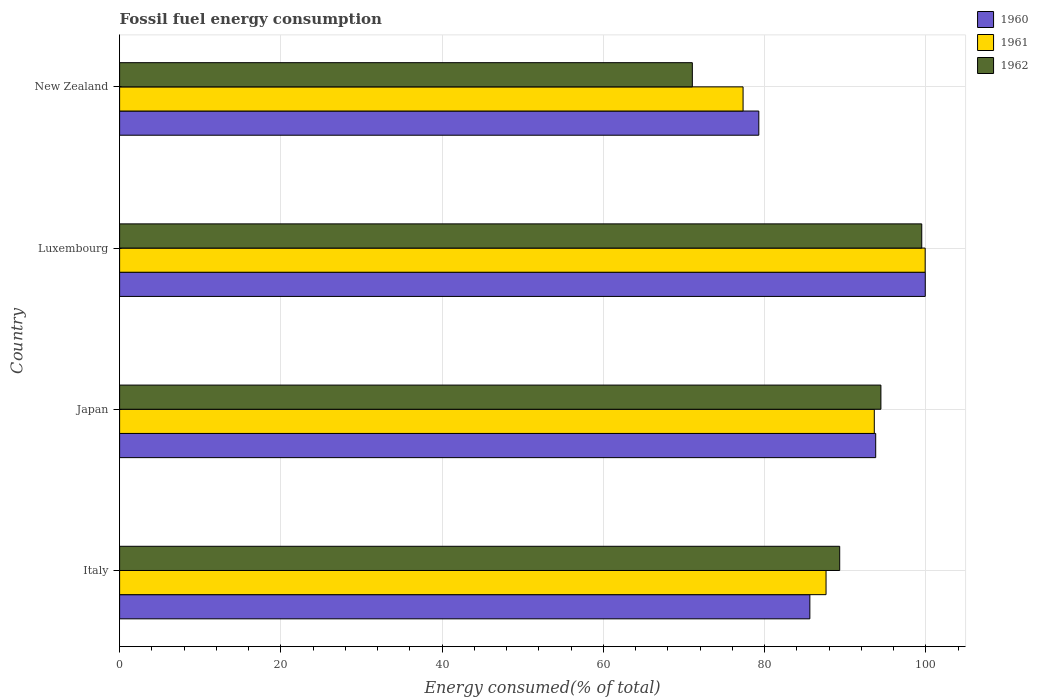How many different coloured bars are there?
Ensure brevity in your answer.  3. Are the number of bars per tick equal to the number of legend labels?
Provide a short and direct response. Yes. Are the number of bars on each tick of the Y-axis equal?
Make the answer very short. Yes. How many bars are there on the 1st tick from the bottom?
Make the answer very short. 3. What is the percentage of energy consumed in 1960 in New Zealand?
Keep it short and to the point. 79.28. Across all countries, what is the maximum percentage of energy consumed in 1960?
Your answer should be compact. 99.92. Across all countries, what is the minimum percentage of energy consumed in 1962?
Provide a succinct answer. 71.04. In which country was the percentage of energy consumed in 1960 maximum?
Keep it short and to the point. Luxembourg. In which country was the percentage of energy consumed in 1961 minimum?
Ensure brevity in your answer.  New Zealand. What is the total percentage of energy consumed in 1962 in the graph?
Your answer should be very brief. 354.26. What is the difference between the percentage of energy consumed in 1961 in Italy and that in Luxembourg?
Offer a very short reply. -12.3. What is the difference between the percentage of energy consumed in 1961 in Italy and the percentage of energy consumed in 1960 in Japan?
Make the answer very short. -6.16. What is the average percentage of energy consumed in 1960 per country?
Offer a very short reply. 89.65. What is the difference between the percentage of energy consumed in 1962 and percentage of energy consumed in 1961 in Japan?
Give a very brief answer. 0.82. What is the ratio of the percentage of energy consumed in 1960 in Japan to that in Luxembourg?
Your answer should be very brief. 0.94. Is the percentage of energy consumed in 1960 in Italy less than that in Japan?
Your answer should be very brief. Yes. Is the difference between the percentage of energy consumed in 1962 in Italy and Luxembourg greater than the difference between the percentage of energy consumed in 1961 in Italy and Luxembourg?
Your answer should be very brief. Yes. What is the difference between the highest and the second highest percentage of energy consumed in 1961?
Make the answer very short. 6.31. What is the difference between the highest and the lowest percentage of energy consumed in 1961?
Offer a terse response. 22.58. Is the sum of the percentage of energy consumed in 1962 in Italy and Japan greater than the maximum percentage of energy consumed in 1960 across all countries?
Ensure brevity in your answer.  Yes. What does the 1st bar from the top in Luxembourg represents?
Offer a terse response. 1962. Is it the case that in every country, the sum of the percentage of energy consumed in 1960 and percentage of energy consumed in 1961 is greater than the percentage of energy consumed in 1962?
Offer a very short reply. Yes. How many countries are there in the graph?
Give a very brief answer. 4. What is the difference between two consecutive major ticks on the X-axis?
Provide a short and direct response. 20. Are the values on the major ticks of X-axis written in scientific E-notation?
Make the answer very short. No. Does the graph contain any zero values?
Offer a very short reply. No. Does the graph contain grids?
Keep it short and to the point. Yes. Where does the legend appear in the graph?
Give a very brief answer. Top right. How are the legend labels stacked?
Offer a very short reply. Vertical. What is the title of the graph?
Offer a terse response. Fossil fuel energy consumption. Does "2002" appear as one of the legend labels in the graph?
Give a very brief answer. No. What is the label or title of the X-axis?
Make the answer very short. Energy consumed(% of total). What is the label or title of the Y-axis?
Provide a short and direct response. Country. What is the Energy consumed(% of total) in 1960 in Italy?
Your answer should be compact. 85.61. What is the Energy consumed(% of total) of 1961 in Italy?
Give a very brief answer. 87.62. What is the Energy consumed(% of total) in 1962 in Italy?
Your answer should be very brief. 89.31. What is the Energy consumed(% of total) in 1960 in Japan?
Your answer should be very brief. 93.78. What is the Energy consumed(% of total) in 1961 in Japan?
Provide a succinct answer. 93.6. What is the Energy consumed(% of total) in 1962 in Japan?
Keep it short and to the point. 94.42. What is the Energy consumed(% of total) in 1960 in Luxembourg?
Provide a succinct answer. 99.92. What is the Energy consumed(% of total) of 1961 in Luxembourg?
Your response must be concise. 99.91. What is the Energy consumed(% of total) of 1962 in Luxembourg?
Make the answer very short. 99.49. What is the Energy consumed(% of total) in 1960 in New Zealand?
Make the answer very short. 79.28. What is the Energy consumed(% of total) in 1961 in New Zealand?
Your response must be concise. 77.33. What is the Energy consumed(% of total) in 1962 in New Zealand?
Offer a terse response. 71.04. Across all countries, what is the maximum Energy consumed(% of total) in 1960?
Your response must be concise. 99.92. Across all countries, what is the maximum Energy consumed(% of total) of 1961?
Provide a succinct answer. 99.91. Across all countries, what is the maximum Energy consumed(% of total) of 1962?
Offer a terse response. 99.49. Across all countries, what is the minimum Energy consumed(% of total) in 1960?
Offer a terse response. 79.28. Across all countries, what is the minimum Energy consumed(% of total) in 1961?
Provide a short and direct response. 77.33. Across all countries, what is the minimum Energy consumed(% of total) of 1962?
Your answer should be compact. 71.04. What is the total Energy consumed(% of total) of 1960 in the graph?
Your response must be concise. 358.59. What is the total Energy consumed(% of total) of 1961 in the graph?
Provide a succinct answer. 358.46. What is the total Energy consumed(% of total) of 1962 in the graph?
Keep it short and to the point. 354.26. What is the difference between the Energy consumed(% of total) in 1960 in Italy and that in Japan?
Keep it short and to the point. -8.17. What is the difference between the Energy consumed(% of total) in 1961 in Italy and that in Japan?
Make the answer very short. -5.99. What is the difference between the Energy consumed(% of total) of 1962 in Italy and that in Japan?
Offer a very short reply. -5.11. What is the difference between the Energy consumed(% of total) of 1960 in Italy and that in Luxembourg?
Offer a terse response. -14.31. What is the difference between the Energy consumed(% of total) in 1961 in Italy and that in Luxembourg?
Make the answer very short. -12.3. What is the difference between the Energy consumed(% of total) in 1962 in Italy and that in Luxembourg?
Give a very brief answer. -10.18. What is the difference between the Energy consumed(% of total) of 1960 in Italy and that in New Zealand?
Provide a succinct answer. 6.33. What is the difference between the Energy consumed(% of total) in 1961 in Italy and that in New Zealand?
Offer a very short reply. 10.29. What is the difference between the Energy consumed(% of total) in 1962 in Italy and that in New Zealand?
Give a very brief answer. 18.27. What is the difference between the Energy consumed(% of total) in 1960 in Japan and that in Luxembourg?
Provide a short and direct response. -6.15. What is the difference between the Energy consumed(% of total) in 1961 in Japan and that in Luxembourg?
Make the answer very short. -6.31. What is the difference between the Energy consumed(% of total) in 1962 in Japan and that in Luxembourg?
Your answer should be compact. -5.07. What is the difference between the Energy consumed(% of total) in 1960 in Japan and that in New Zealand?
Your response must be concise. 14.5. What is the difference between the Energy consumed(% of total) of 1961 in Japan and that in New Zealand?
Ensure brevity in your answer.  16.28. What is the difference between the Energy consumed(% of total) in 1962 in Japan and that in New Zealand?
Keep it short and to the point. 23.38. What is the difference between the Energy consumed(% of total) in 1960 in Luxembourg and that in New Zealand?
Make the answer very short. 20.65. What is the difference between the Energy consumed(% of total) in 1961 in Luxembourg and that in New Zealand?
Your answer should be very brief. 22.58. What is the difference between the Energy consumed(% of total) of 1962 in Luxembourg and that in New Zealand?
Provide a succinct answer. 28.45. What is the difference between the Energy consumed(% of total) of 1960 in Italy and the Energy consumed(% of total) of 1961 in Japan?
Your answer should be compact. -7.99. What is the difference between the Energy consumed(% of total) in 1960 in Italy and the Energy consumed(% of total) in 1962 in Japan?
Ensure brevity in your answer.  -8.81. What is the difference between the Energy consumed(% of total) in 1961 in Italy and the Energy consumed(% of total) in 1962 in Japan?
Make the answer very short. -6.8. What is the difference between the Energy consumed(% of total) of 1960 in Italy and the Energy consumed(% of total) of 1961 in Luxembourg?
Offer a terse response. -14.3. What is the difference between the Energy consumed(% of total) of 1960 in Italy and the Energy consumed(% of total) of 1962 in Luxembourg?
Provide a succinct answer. -13.88. What is the difference between the Energy consumed(% of total) of 1961 in Italy and the Energy consumed(% of total) of 1962 in Luxembourg?
Your answer should be very brief. -11.87. What is the difference between the Energy consumed(% of total) in 1960 in Italy and the Energy consumed(% of total) in 1961 in New Zealand?
Ensure brevity in your answer.  8.28. What is the difference between the Energy consumed(% of total) in 1960 in Italy and the Energy consumed(% of total) in 1962 in New Zealand?
Your response must be concise. 14.57. What is the difference between the Energy consumed(% of total) of 1961 in Italy and the Energy consumed(% of total) of 1962 in New Zealand?
Provide a short and direct response. 16.58. What is the difference between the Energy consumed(% of total) of 1960 in Japan and the Energy consumed(% of total) of 1961 in Luxembourg?
Provide a short and direct response. -6.14. What is the difference between the Energy consumed(% of total) in 1960 in Japan and the Energy consumed(% of total) in 1962 in Luxembourg?
Ensure brevity in your answer.  -5.71. What is the difference between the Energy consumed(% of total) in 1961 in Japan and the Energy consumed(% of total) in 1962 in Luxembourg?
Your answer should be very brief. -5.88. What is the difference between the Energy consumed(% of total) of 1960 in Japan and the Energy consumed(% of total) of 1961 in New Zealand?
Your answer should be very brief. 16.45. What is the difference between the Energy consumed(% of total) in 1960 in Japan and the Energy consumed(% of total) in 1962 in New Zealand?
Ensure brevity in your answer.  22.74. What is the difference between the Energy consumed(% of total) of 1961 in Japan and the Energy consumed(% of total) of 1962 in New Zealand?
Give a very brief answer. 22.57. What is the difference between the Energy consumed(% of total) of 1960 in Luxembourg and the Energy consumed(% of total) of 1961 in New Zealand?
Make the answer very short. 22.6. What is the difference between the Energy consumed(% of total) in 1960 in Luxembourg and the Energy consumed(% of total) in 1962 in New Zealand?
Give a very brief answer. 28.89. What is the difference between the Energy consumed(% of total) of 1961 in Luxembourg and the Energy consumed(% of total) of 1962 in New Zealand?
Ensure brevity in your answer.  28.88. What is the average Energy consumed(% of total) of 1960 per country?
Your response must be concise. 89.65. What is the average Energy consumed(% of total) in 1961 per country?
Provide a succinct answer. 89.62. What is the average Energy consumed(% of total) in 1962 per country?
Offer a terse response. 88.56. What is the difference between the Energy consumed(% of total) of 1960 and Energy consumed(% of total) of 1961 in Italy?
Your answer should be compact. -2.01. What is the difference between the Energy consumed(% of total) in 1960 and Energy consumed(% of total) in 1962 in Italy?
Provide a succinct answer. -3.7. What is the difference between the Energy consumed(% of total) of 1961 and Energy consumed(% of total) of 1962 in Italy?
Offer a very short reply. -1.69. What is the difference between the Energy consumed(% of total) in 1960 and Energy consumed(% of total) in 1961 in Japan?
Your answer should be compact. 0.17. What is the difference between the Energy consumed(% of total) of 1960 and Energy consumed(% of total) of 1962 in Japan?
Provide a succinct answer. -0.64. What is the difference between the Energy consumed(% of total) of 1961 and Energy consumed(% of total) of 1962 in Japan?
Give a very brief answer. -0.82. What is the difference between the Energy consumed(% of total) of 1960 and Energy consumed(% of total) of 1961 in Luxembourg?
Provide a succinct answer. 0.01. What is the difference between the Energy consumed(% of total) of 1960 and Energy consumed(% of total) of 1962 in Luxembourg?
Offer a very short reply. 0.44. What is the difference between the Energy consumed(% of total) in 1961 and Energy consumed(% of total) in 1962 in Luxembourg?
Ensure brevity in your answer.  0.42. What is the difference between the Energy consumed(% of total) in 1960 and Energy consumed(% of total) in 1961 in New Zealand?
Your answer should be compact. 1.95. What is the difference between the Energy consumed(% of total) of 1960 and Energy consumed(% of total) of 1962 in New Zealand?
Keep it short and to the point. 8.24. What is the difference between the Energy consumed(% of total) in 1961 and Energy consumed(% of total) in 1962 in New Zealand?
Offer a very short reply. 6.29. What is the ratio of the Energy consumed(% of total) of 1960 in Italy to that in Japan?
Offer a very short reply. 0.91. What is the ratio of the Energy consumed(% of total) of 1961 in Italy to that in Japan?
Your answer should be compact. 0.94. What is the ratio of the Energy consumed(% of total) of 1962 in Italy to that in Japan?
Your answer should be compact. 0.95. What is the ratio of the Energy consumed(% of total) of 1960 in Italy to that in Luxembourg?
Offer a terse response. 0.86. What is the ratio of the Energy consumed(% of total) of 1961 in Italy to that in Luxembourg?
Provide a succinct answer. 0.88. What is the ratio of the Energy consumed(% of total) of 1962 in Italy to that in Luxembourg?
Provide a succinct answer. 0.9. What is the ratio of the Energy consumed(% of total) of 1960 in Italy to that in New Zealand?
Give a very brief answer. 1.08. What is the ratio of the Energy consumed(% of total) of 1961 in Italy to that in New Zealand?
Offer a very short reply. 1.13. What is the ratio of the Energy consumed(% of total) of 1962 in Italy to that in New Zealand?
Offer a very short reply. 1.26. What is the ratio of the Energy consumed(% of total) in 1960 in Japan to that in Luxembourg?
Offer a very short reply. 0.94. What is the ratio of the Energy consumed(% of total) in 1961 in Japan to that in Luxembourg?
Keep it short and to the point. 0.94. What is the ratio of the Energy consumed(% of total) in 1962 in Japan to that in Luxembourg?
Ensure brevity in your answer.  0.95. What is the ratio of the Energy consumed(% of total) in 1960 in Japan to that in New Zealand?
Provide a succinct answer. 1.18. What is the ratio of the Energy consumed(% of total) in 1961 in Japan to that in New Zealand?
Give a very brief answer. 1.21. What is the ratio of the Energy consumed(% of total) in 1962 in Japan to that in New Zealand?
Your answer should be compact. 1.33. What is the ratio of the Energy consumed(% of total) of 1960 in Luxembourg to that in New Zealand?
Keep it short and to the point. 1.26. What is the ratio of the Energy consumed(% of total) of 1961 in Luxembourg to that in New Zealand?
Your response must be concise. 1.29. What is the ratio of the Energy consumed(% of total) of 1962 in Luxembourg to that in New Zealand?
Your response must be concise. 1.4. What is the difference between the highest and the second highest Energy consumed(% of total) in 1960?
Offer a very short reply. 6.15. What is the difference between the highest and the second highest Energy consumed(% of total) in 1961?
Provide a short and direct response. 6.31. What is the difference between the highest and the second highest Energy consumed(% of total) in 1962?
Offer a very short reply. 5.07. What is the difference between the highest and the lowest Energy consumed(% of total) in 1960?
Offer a very short reply. 20.65. What is the difference between the highest and the lowest Energy consumed(% of total) in 1961?
Your answer should be very brief. 22.58. What is the difference between the highest and the lowest Energy consumed(% of total) of 1962?
Keep it short and to the point. 28.45. 